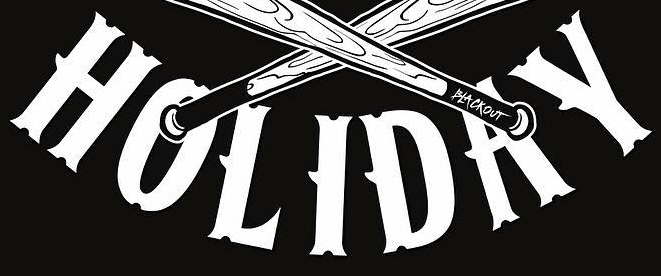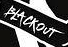Identify the words shown in these images in order, separated by a semicolon. HOLIDAY; BLACKOUT 